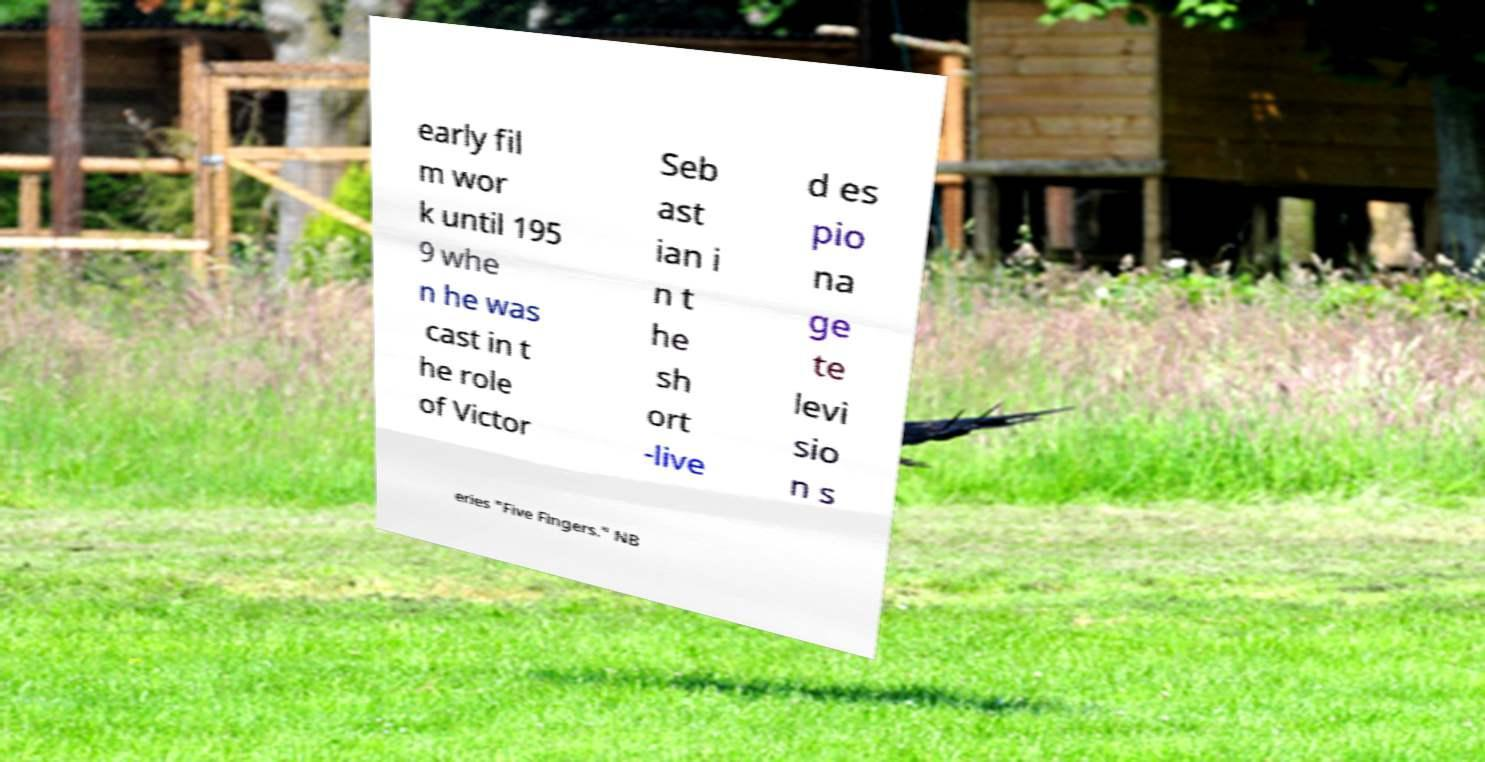There's text embedded in this image that I need extracted. Can you transcribe it verbatim? early fil m wor k until 195 9 whe n he was cast in t he role of Victor Seb ast ian i n t he sh ort -live d es pio na ge te levi sio n s eries "Five Fingers." NB 